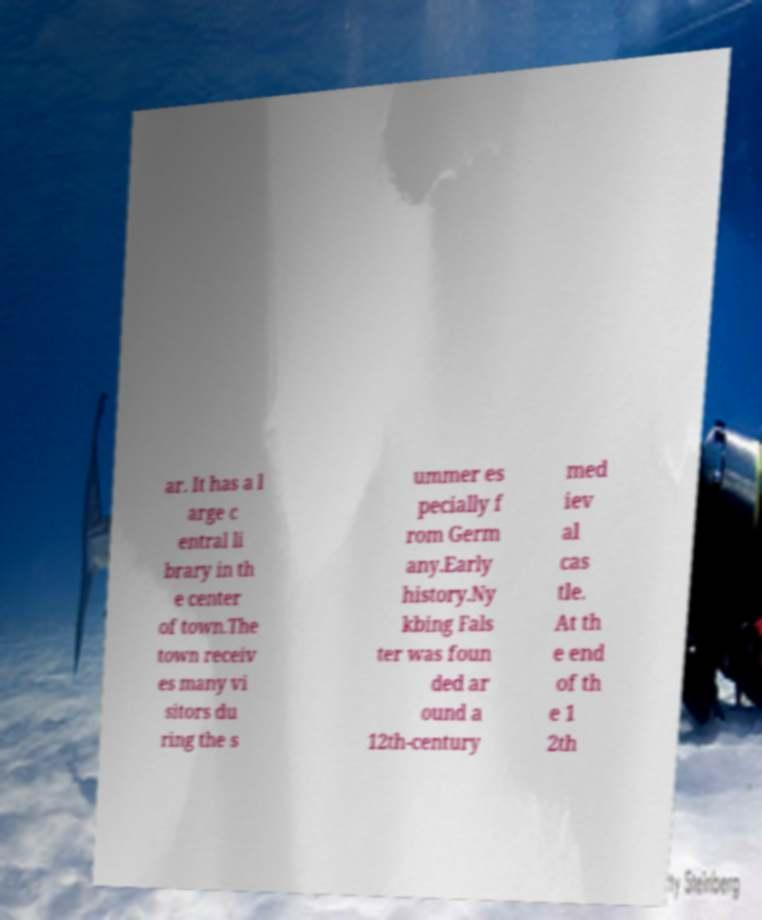Could you extract and type out the text from this image? ar. It has a l arge c entral li brary in th e center of town.The town receiv es many vi sitors du ring the s ummer es pecially f rom Germ any.Early history.Ny kbing Fals ter was foun ded ar ound a 12th-century med iev al cas tle. At th e end of th e 1 2th 